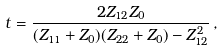Convert formula to latex. <formula><loc_0><loc_0><loc_500><loc_500>t = \frac { 2 Z _ { 1 2 } Z _ { 0 } } { ( Z _ { 1 1 } + Z _ { 0 } ) ( Z _ { 2 2 } + Z _ { 0 } ) - Z _ { 1 2 } ^ { 2 } } \, ,</formula> 